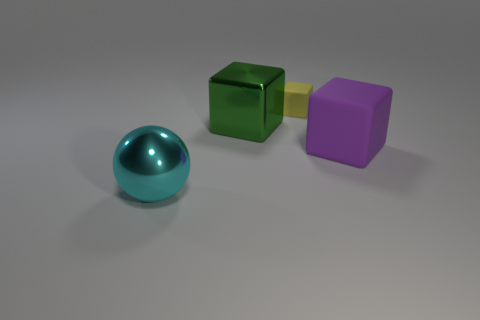Add 1 big yellow metallic objects. How many objects exist? 5 Subtract all balls. How many objects are left? 3 Subtract all large matte blocks. Subtract all large green metallic cylinders. How many objects are left? 3 Add 3 purple rubber things. How many purple rubber things are left? 4 Add 1 large cyan shiny objects. How many large cyan shiny objects exist? 2 Subtract 0 red blocks. How many objects are left? 4 